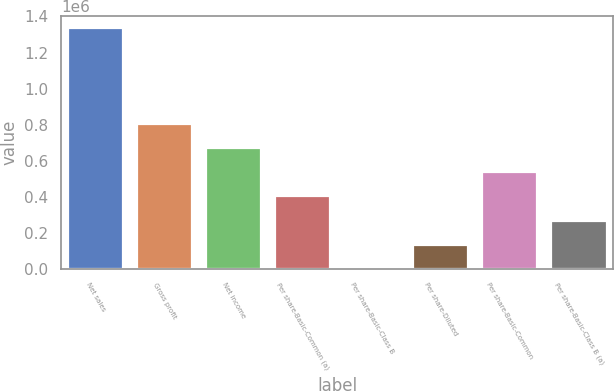<chart> <loc_0><loc_0><loc_500><loc_500><bar_chart><fcel>Net sales<fcel>Gross profit<fcel>Net income<fcel>Per share-Basic-Common (a)<fcel>Per share-Basic-Class B<fcel>Per share-Diluted<fcel>Per share-Basic-Common<fcel>Per share-Basic-Class B (a)<nl><fcel>1.33661e+06<fcel>801966<fcel>668305<fcel>400983<fcel>0.61<fcel>133661<fcel>534644<fcel>267322<nl></chart> 